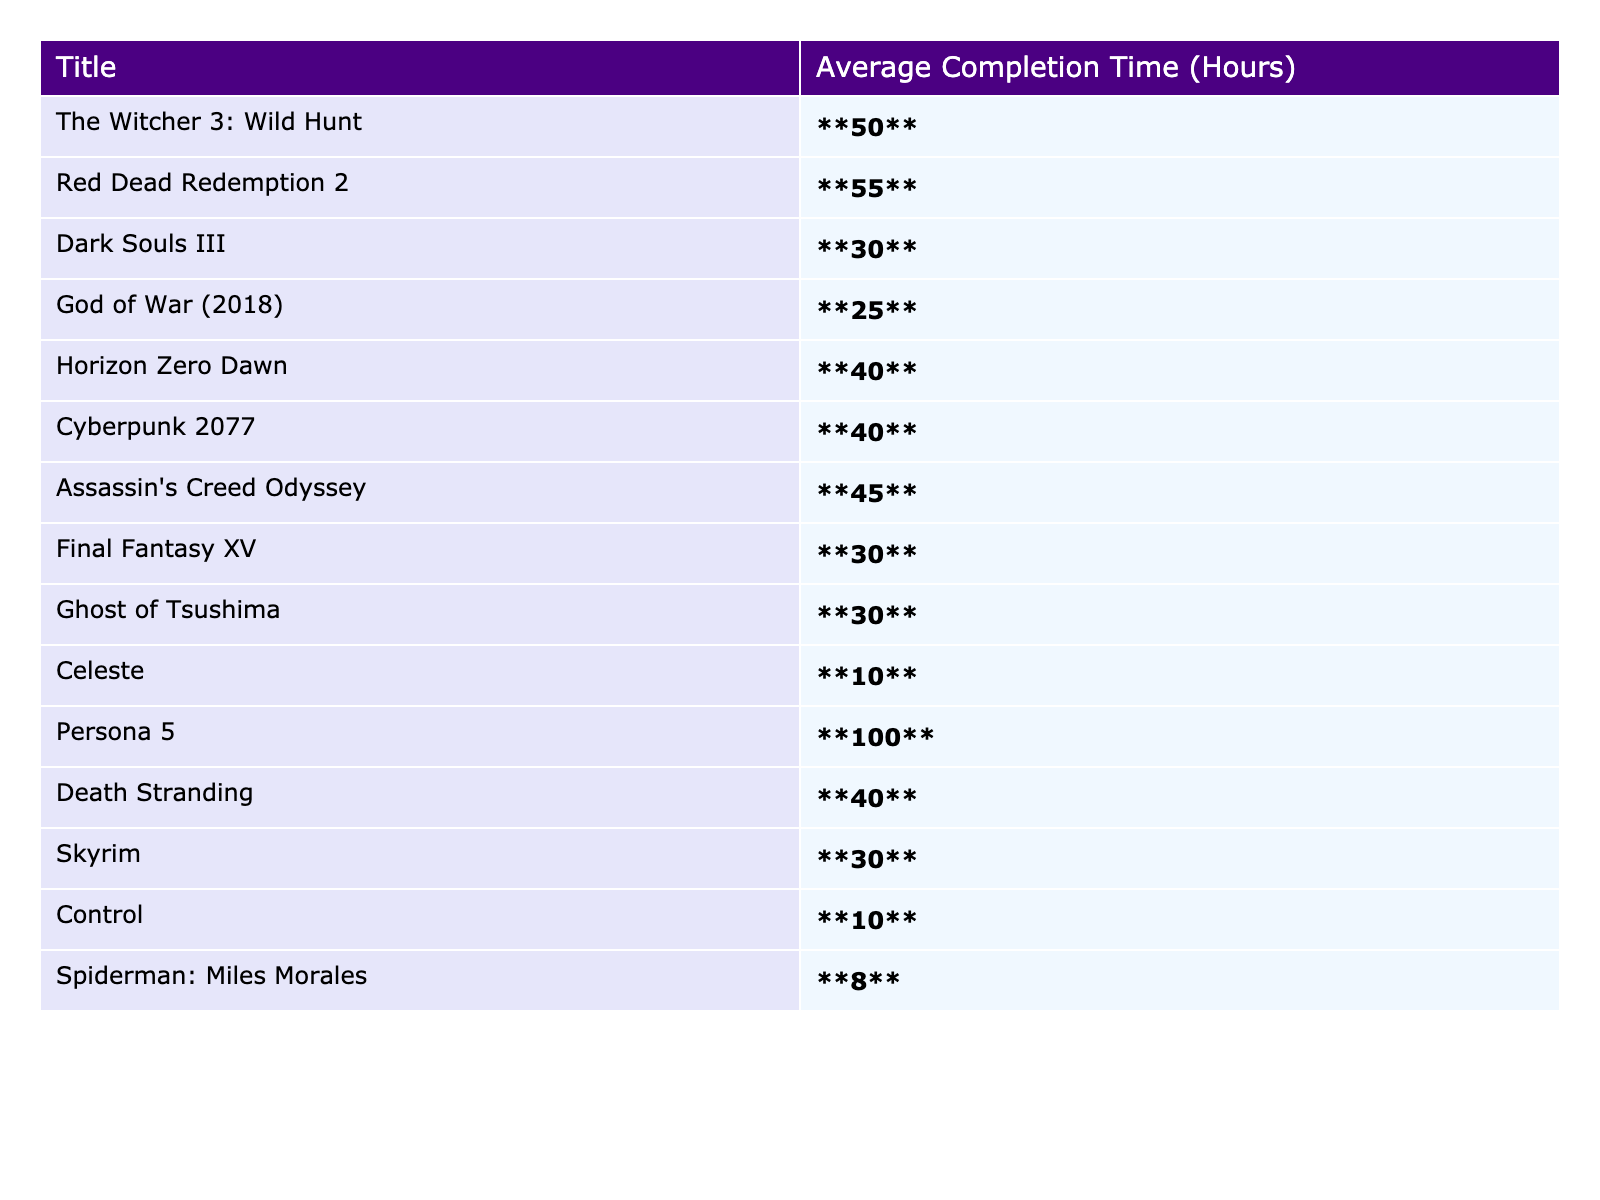What is the average completion time for "The Witcher 3: Wild Hunt"? The completion time for "The Witcher 3: Wild Hunt" is specifically listed in the table as **50** hours.
Answer: 50 hours Which game has the longest average completion time? Looking at the table, "Persona 5" has the highest bolded value at **100** hours, indicating it has the longest average completion time among the listed games.
Answer: Persona 5 How many games have an average completion time of less than 30 hours? From the table, "Celeste" (**10**), "Control" (**10**), and "Spiderman: Miles Morales" (**8**) are the only titles below 30 hours. That's a total of 3 games.
Answer: 3 games Find the difference in average completion time between "God of War (2018)" and "Horizon Zero Dawn". "God of War (2018)" has an average of **25** hours and "Horizon Zero Dawn" has **40** hours. The difference is calculated as 40 - 25 = 15 hours.
Answer: 15 hours Is the average completion time for "Red Dead Redemption 2" greater than 50 hours? The table shows that "Red Dead Redemption 2" has an average completion time of **55** hours, which is indeed greater than 50 hours.
Answer: Yes What is the average completion time for the top three longest games? The top three longest games are "Persona 5" (100 hours), "Red Dead Redemption 2" (55 hours), and "The Witcher 3: Wild Hunt" (50 hours). Their total is 100 + 55 + 50 = 205 hours. Dividing by 3 gives an average of 205/3 ≈ 68.33 hours.
Answer: 68.33 hours How many titles in the table have an average completion time of 40 hours or more? The titles with completion times of 40 hours or more are "Red Dead Redemption 2" (55), "The Witcher 3" (50), "Assassin's Creed Odyssey" (45), "Cyberpunk 2077" (40), "Horizon Zero Dawn" (40), and "Death Stranding" (40). This totals to 6 titles.
Answer: 6 titles What is the median completion time for the games listed? To find the median, we first list the average completion times in ascending order: 8, 10, 10, 25, 30, 30, 30, 30, 40, 40, 40, 45, 50, 55, 100. There are 15 values, so the median is the 8th value, which is **30** hours.
Answer: 30 hours Which game is the least time-consuming based on the average completion time? The least amount of time spent is for "Spiderman: Miles Morales," which shows an average of **8** hours in the table.
Answer: Spiderman: Miles Morales Calculate the total average completion time for all listed games. Summing up all the average times: 50 + 55 + 30 + 25 + 40 + 40 + 45 + 30 + 30 + 10 + 100 + 40 + 30 + 10 + 8 =  600 hours.
Answer: 600 hours 